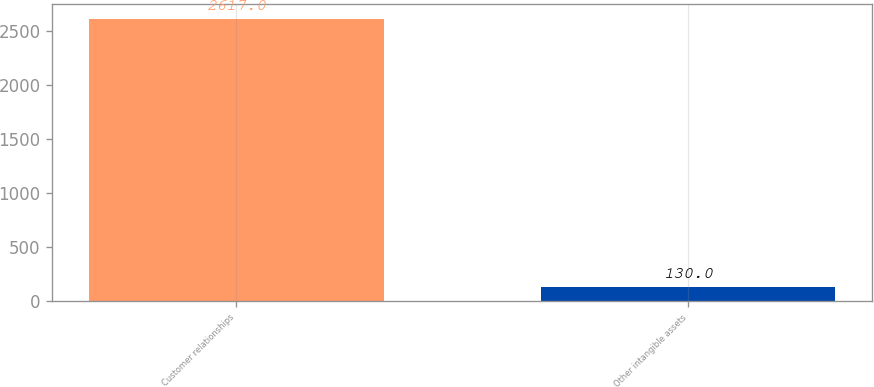Convert chart. <chart><loc_0><loc_0><loc_500><loc_500><bar_chart><fcel>Customer relationships<fcel>Other intangible assets<nl><fcel>2617<fcel>130<nl></chart> 